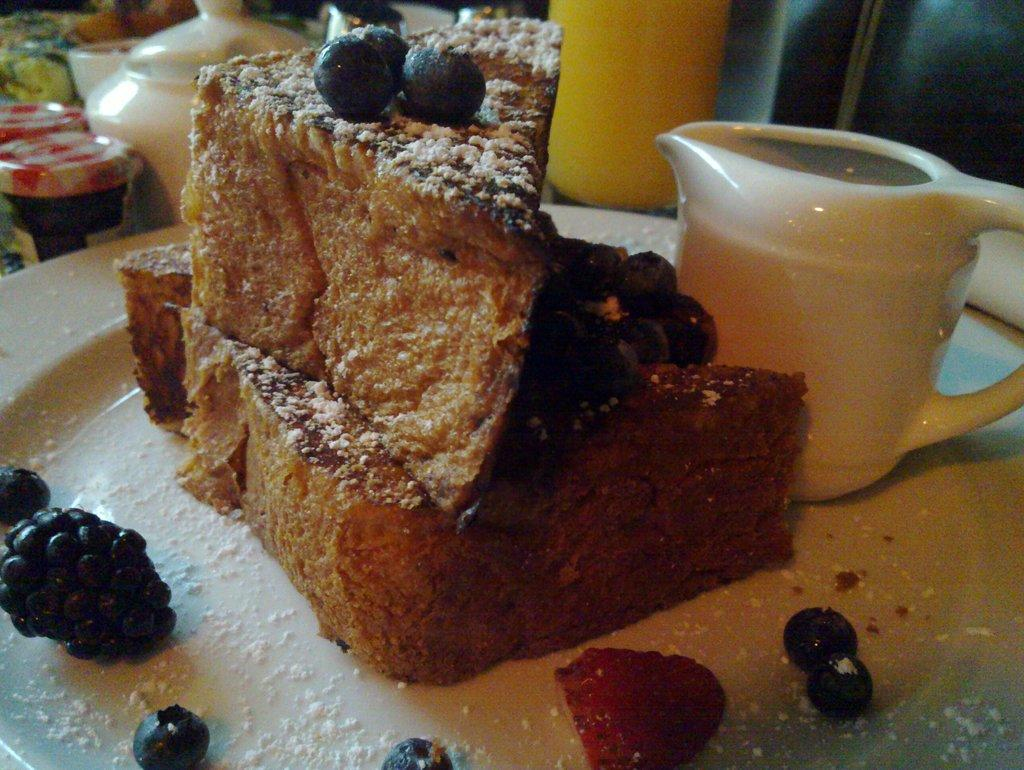What is on the plate in the image? There is a cup on the plate, and there are food items on the plate. What is the color of the plate? The plate is white. What is in front of the plate in the image? There are objects in front of the plate. How many apples are on the plate in the image? There is no mention of apples in the image; the food items on the plate are not specified. 